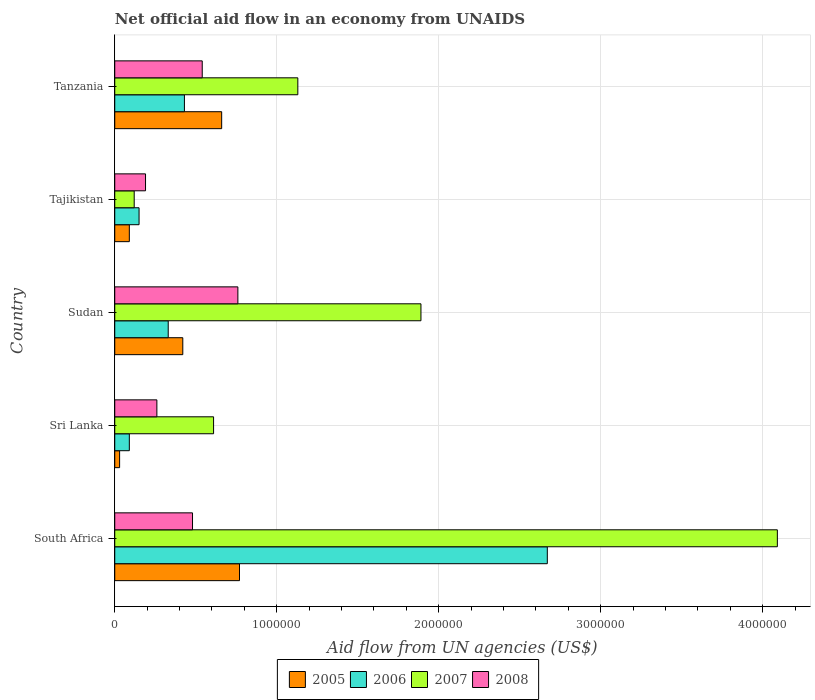Are the number of bars per tick equal to the number of legend labels?
Give a very brief answer. Yes. Are the number of bars on each tick of the Y-axis equal?
Ensure brevity in your answer.  Yes. How many bars are there on the 2nd tick from the top?
Give a very brief answer. 4. What is the label of the 5th group of bars from the top?
Ensure brevity in your answer.  South Africa. In how many cases, is the number of bars for a given country not equal to the number of legend labels?
Your response must be concise. 0. What is the net official aid flow in 2008 in Tajikistan?
Your response must be concise. 1.90e+05. Across all countries, what is the maximum net official aid flow in 2006?
Your response must be concise. 2.67e+06. In which country was the net official aid flow in 2007 maximum?
Your answer should be very brief. South Africa. In which country was the net official aid flow in 2007 minimum?
Ensure brevity in your answer.  Tajikistan. What is the total net official aid flow in 2007 in the graph?
Your response must be concise. 7.84e+06. What is the average net official aid flow in 2006 per country?
Provide a short and direct response. 7.34e+05. What is the difference between the net official aid flow in 2006 and net official aid flow in 2007 in Tanzania?
Give a very brief answer. -7.00e+05. In how many countries, is the net official aid flow in 2007 greater than 2000000 US$?
Give a very brief answer. 1. What is the ratio of the net official aid flow in 2005 in South Africa to that in Sri Lanka?
Provide a succinct answer. 25.67. What is the difference between the highest and the second highest net official aid flow in 2005?
Give a very brief answer. 1.10e+05. What is the difference between the highest and the lowest net official aid flow in 2007?
Your answer should be compact. 3.97e+06. Is it the case that in every country, the sum of the net official aid flow in 2008 and net official aid flow in 2007 is greater than the sum of net official aid flow in 2006 and net official aid flow in 2005?
Ensure brevity in your answer.  No. Is it the case that in every country, the sum of the net official aid flow in 2006 and net official aid flow in 2008 is greater than the net official aid flow in 2005?
Make the answer very short. Yes. What is the difference between two consecutive major ticks on the X-axis?
Offer a terse response. 1.00e+06. Does the graph contain grids?
Offer a very short reply. Yes. How are the legend labels stacked?
Give a very brief answer. Horizontal. What is the title of the graph?
Your answer should be compact. Net official aid flow in an economy from UNAIDS. What is the label or title of the X-axis?
Ensure brevity in your answer.  Aid flow from UN agencies (US$). What is the Aid flow from UN agencies (US$) in 2005 in South Africa?
Offer a very short reply. 7.70e+05. What is the Aid flow from UN agencies (US$) in 2006 in South Africa?
Give a very brief answer. 2.67e+06. What is the Aid flow from UN agencies (US$) in 2007 in South Africa?
Provide a short and direct response. 4.09e+06. What is the Aid flow from UN agencies (US$) in 2008 in South Africa?
Keep it short and to the point. 4.80e+05. What is the Aid flow from UN agencies (US$) in 2006 in Sri Lanka?
Make the answer very short. 9.00e+04. What is the Aid flow from UN agencies (US$) in 2005 in Sudan?
Provide a short and direct response. 4.20e+05. What is the Aid flow from UN agencies (US$) of 2006 in Sudan?
Offer a terse response. 3.30e+05. What is the Aid flow from UN agencies (US$) in 2007 in Sudan?
Give a very brief answer. 1.89e+06. What is the Aid flow from UN agencies (US$) in 2008 in Sudan?
Give a very brief answer. 7.60e+05. What is the Aid flow from UN agencies (US$) in 2005 in Tajikistan?
Ensure brevity in your answer.  9.00e+04. What is the Aid flow from UN agencies (US$) in 2007 in Tajikistan?
Keep it short and to the point. 1.20e+05. What is the Aid flow from UN agencies (US$) in 2008 in Tajikistan?
Ensure brevity in your answer.  1.90e+05. What is the Aid flow from UN agencies (US$) in 2005 in Tanzania?
Make the answer very short. 6.60e+05. What is the Aid flow from UN agencies (US$) of 2006 in Tanzania?
Your response must be concise. 4.30e+05. What is the Aid flow from UN agencies (US$) of 2007 in Tanzania?
Ensure brevity in your answer.  1.13e+06. What is the Aid flow from UN agencies (US$) of 2008 in Tanzania?
Keep it short and to the point. 5.40e+05. Across all countries, what is the maximum Aid flow from UN agencies (US$) of 2005?
Your answer should be compact. 7.70e+05. Across all countries, what is the maximum Aid flow from UN agencies (US$) of 2006?
Offer a very short reply. 2.67e+06. Across all countries, what is the maximum Aid flow from UN agencies (US$) of 2007?
Your response must be concise. 4.09e+06. Across all countries, what is the maximum Aid flow from UN agencies (US$) of 2008?
Offer a very short reply. 7.60e+05. Across all countries, what is the minimum Aid flow from UN agencies (US$) in 2005?
Offer a very short reply. 3.00e+04. Across all countries, what is the minimum Aid flow from UN agencies (US$) of 2008?
Make the answer very short. 1.90e+05. What is the total Aid flow from UN agencies (US$) of 2005 in the graph?
Provide a succinct answer. 1.97e+06. What is the total Aid flow from UN agencies (US$) of 2006 in the graph?
Your response must be concise. 3.67e+06. What is the total Aid flow from UN agencies (US$) in 2007 in the graph?
Provide a succinct answer. 7.84e+06. What is the total Aid flow from UN agencies (US$) of 2008 in the graph?
Offer a terse response. 2.23e+06. What is the difference between the Aid flow from UN agencies (US$) in 2005 in South Africa and that in Sri Lanka?
Provide a succinct answer. 7.40e+05. What is the difference between the Aid flow from UN agencies (US$) in 2006 in South Africa and that in Sri Lanka?
Make the answer very short. 2.58e+06. What is the difference between the Aid flow from UN agencies (US$) in 2007 in South Africa and that in Sri Lanka?
Ensure brevity in your answer.  3.48e+06. What is the difference between the Aid flow from UN agencies (US$) in 2008 in South Africa and that in Sri Lanka?
Provide a succinct answer. 2.20e+05. What is the difference between the Aid flow from UN agencies (US$) of 2006 in South Africa and that in Sudan?
Make the answer very short. 2.34e+06. What is the difference between the Aid flow from UN agencies (US$) in 2007 in South Africa and that in Sudan?
Give a very brief answer. 2.20e+06. What is the difference between the Aid flow from UN agencies (US$) of 2008 in South Africa and that in Sudan?
Offer a very short reply. -2.80e+05. What is the difference between the Aid flow from UN agencies (US$) of 2005 in South Africa and that in Tajikistan?
Your answer should be compact. 6.80e+05. What is the difference between the Aid flow from UN agencies (US$) in 2006 in South Africa and that in Tajikistan?
Your answer should be very brief. 2.52e+06. What is the difference between the Aid flow from UN agencies (US$) in 2007 in South Africa and that in Tajikistan?
Your answer should be very brief. 3.97e+06. What is the difference between the Aid flow from UN agencies (US$) of 2008 in South Africa and that in Tajikistan?
Ensure brevity in your answer.  2.90e+05. What is the difference between the Aid flow from UN agencies (US$) in 2006 in South Africa and that in Tanzania?
Provide a succinct answer. 2.24e+06. What is the difference between the Aid flow from UN agencies (US$) of 2007 in South Africa and that in Tanzania?
Your answer should be very brief. 2.96e+06. What is the difference between the Aid flow from UN agencies (US$) in 2005 in Sri Lanka and that in Sudan?
Your answer should be very brief. -3.90e+05. What is the difference between the Aid flow from UN agencies (US$) of 2006 in Sri Lanka and that in Sudan?
Give a very brief answer. -2.40e+05. What is the difference between the Aid flow from UN agencies (US$) in 2007 in Sri Lanka and that in Sudan?
Your answer should be very brief. -1.28e+06. What is the difference between the Aid flow from UN agencies (US$) in 2008 in Sri Lanka and that in Sudan?
Your answer should be compact. -5.00e+05. What is the difference between the Aid flow from UN agencies (US$) of 2005 in Sri Lanka and that in Tanzania?
Your answer should be compact. -6.30e+05. What is the difference between the Aid flow from UN agencies (US$) of 2007 in Sri Lanka and that in Tanzania?
Provide a succinct answer. -5.20e+05. What is the difference between the Aid flow from UN agencies (US$) of 2008 in Sri Lanka and that in Tanzania?
Keep it short and to the point. -2.80e+05. What is the difference between the Aid flow from UN agencies (US$) in 2005 in Sudan and that in Tajikistan?
Give a very brief answer. 3.30e+05. What is the difference between the Aid flow from UN agencies (US$) of 2007 in Sudan and that in Tajikistan?
Your response must be concise. 1.77e+06. What is the difference between the Aid flow from UN agencies (US$) of 2008 in Sudan and that in Tajikistan?
Your answer should be very brief. 5.70e+05. What is the difference between the Aid flow from UN agencies (US$) in 2005 in Sudan and that in Tanzania?
Your answer should be very brief. -2.40e+05. What is the difference between the Aid flow from UN agencies (US$) of 2006 in Sudan and that in Tanzania?
Your answer should be very brief. -1.00e+05. What is the difference between the Aid flow from UN agencies (US$) in 2007 in Sudan and that in Tanzania?
Your answer should be very brief. 7.60e+05. What is the difference between the Aid flow from UN agencies (US$) in 2005 in Tajikistan and that in Tanzania?
Provide a short and direct response. -5.70e+05. What is the difference between the Aid flow from UN agencies (US$) in 2006 in Tajikistan and that in Tanzania?
Your answer should be very brief. -2.80e+05. What is the difference between the Aid flow from UN agencies (US$) in 2007 in Tajikistan and that in Tanzania?
Give a very brief answer. -1.01e+06. What is the difference between the Aid flow from UN agencies (US$) of 2008 in Tajikistan and that in Tanzania?
Provide a succinct answer. -3.50e+05. What is the difference between the Aid flow from UN agencies (US$) in 2005 in South Africa and the Aid flow from UN agencies (US$) in 2006 in Sri Lanka?
Your answer should be very brief. 6.80e+05. What is the difference between the Aid flow from UN agencies (US$) in 2005 in South Africa and the Aid flow from UN agencies (US$) in 2007 in Sri Lanka?
Offer a terse response. 1.60e+05. What is the difference between the Aid flow from UN agencies (US$) of 2005 in South Africa and the Aid flow from UN agencies (US$) of 2008 in Sri Lanka?
Offer a very short reply. 5.10e+05. What is the difference between the Aid flow from UN agencies (US$) in 2006 in South Africa and the Aid flow from UN agencies (US$) in 2007 in Sri Lanka?
Your response must be concise. 2.06e+06. What is the difference between the Aid flow from UN agencies (US$) in 2006 in South Africa and the Aid flow from UN agencies (US$) in 2008 in Sri Lanka?
Your response must be concise. 2.41e+06. What is the difference between the Aid flow from UN agencies (US$) of 2007 in South Africa and the Aid flow from UN agencies (US$) of 2008 in Sri Lanka?
Your answer should be very brief. 3.83e+06. What is the difference between the Aid flow from UN agencies (US$) in 2005 in South Africa and the Aid flow from UN agencies (US$) in 2006 in Sudan?
Offer a very short reply. 4.40e+05. What is the difference between the Aid flow from UN agencies (US$) of 2005 in South Africa and the Aid flow from UN agencies (US$) of 2007 in Sudan?
Provide a succinct answer. -1.12e+06. What is the difference between the Aid flow from UN agencies (US$) in 2006 in South Africa and the Aid flow from UN agencies (US$) in 2007 in Sudan?
Your answer should be compact. 7.80e+05. What is the difference between the Aid flow from UN agencies (US$) of 2006 in South Africa and the Aid flow from UN agencies (US$) of 2008 in Sudan?
Provide a short and direct response. 1.91e+06. What is the difference between the Aid flow from UN agencies (US$) in 2007 in South Africa and the Aid flow from UN agencies (US$) in 2008 in Sudan?
Provide a short and direct response. 3.33e+06. What is the difference between the Aid flow from UN agencies (US$) in 2005 in South Africa and the Aid flow from UN agencies (US$) in 2006 in Tajikistan?
Keep it short and to the point. 6.20e+05. What is the difference between the Aid flow from UN agencies (US$) of 2005 in South Africa and the Aid flow from UN agencies (US$) of 2007 in Tajikistan?
Your response must be concise. 6.50e+05. What is the difference between the Aid flow from UN agencies (US$) in 2005 in South Africa and the Aid flow from UN agencies (US$) in 2008 in Tajikistan?
Offer a terse response. 5.80e+05. What is the difference between the Aid flow from UN agencies (US$) in 2006 in South Africa and the Aid flow from UN agencies (US$) in 2007 in Tajikistan?
Provide a short and direct response. 2.55e+06. What is the difference between the Aid flow from UN agencies (US$) of 2006 in South Africa and the Aid flow from UN agencies (US$) of 2008 in Tajikistan?
Offer a very short reply. 2.48e+06. What is the difference between the Aid flow from UN agencies (US$) of 2007 in South Africa and the Aid flow from UN agencies (US$) of 2008 in Tajikistan?
Your answer should be very brief. 3.90e+06. What is the difference between the Aid flow from UN agencies (US$) of 2005 in South Africa and the Aid flow from UN agencies (US$) of 2006 in Tanzania?
Ensure brevity in your answer.  3.40e+05. What is the difference between the Aid flow from UN agencies (US$) in 2005 in South Africa and the Aid flow from UN agencies (US$) in 2007 in Tanzania?
Offer a terse response. -3.60e+05. What is the difference between the Aid flow from UN agencies (US$) of 2006 in South Africa and the Aid flow from UN agencies (US$) of 2007 in Tanzania?
Offer a terse response. 1.54e+06. What is the difference between the Aid flow from UN agencies (US$) of 2006 in South Africa and the Aid flow from UN agencies (US$) of 2008 in Tanzania?
Give a very brief answer. 2.13e+06. What is the difference between the Aid flow from UN agencies (US$) in 2007 in South Africa and the Aid flow from UN agencies (US$) in 2008 in Tanzania?
Your answer should be compact. 3.55e+06. What is the difference between the Aid flow from UN agencies (US$) in 2005 in Sri Lanka and the Aid flow from UN agencies (US$) in 2007 in Sudan?
Provide a succinct answer. -1.86e+06. What is the difference between the Aid flow from UN agencies (US$) in 2005 in Sri Lanka and the Aid flow from UN agencies (US$) in 2008 in Sudan?
Your answer should be compact. -7.30e+05. What is the difference between the Aid flow from UN agencies (US$) in 2006 in Sri Lanka and the Aid flow from UN agencies (US$) in 2007 in Sudan?
Ensure brevity in your answer.  -1.80e+06. What is the difference between the Aid flow from UN agencies (US$) in 2006 in Sri Lanka and the Aid flow from UN agencies (US$) in 2008 in Sudan?
Give a very brief answer. -6.70e+05. What is the difference between the Aid flow from UN agencies (US$) of 2005 in Sri Lanka and the Aid flow from UN agencies (US$) of 2007 in Tajikistan?
Keep it short and to the point. -9.00e+04. What is the difference between the Aid flow from UN agencies (US$) in 2006 in Sri Lanka and the Aid flow from UN agencies (US$) in 2008 in Tajikistan?
Offer a very short reply. -1.00e+05. What is the difference between the Aid flow from UN agencies (US$) in 2007 in Sri Lanka and the Aid flow from UN agencies (US$) in 2008 in Tajikistan?
Ensure brevity in your answer.  4.20e+05. What is the difference between the Aid flow from UN agencies (US$) of 2005 in Sri Lanka and the Aid flow from UN agencies (US$) of 2006 in Tanzania?
Offer a very short reply. -4.00e+05. What is the difference between the Aid flow from UN agencies (US$) in 2005 in Sri Lanka and the Aid flow from UN agencies (US$) in 2007 in Tanzania?
Your answer should be very brief. -1.10e+06. What is the difference between the Aid flow from UN agencies (US$) of 2005 in Sri Lanka and the Aid flow from UN agencies (US$) of 2008 in Tanzania?
Ensure brevity in your answer.  -5.10e+05. What is the difference between the Aid flow from UN agencies (US$) of 2006 in Sri Lanka and the Aid flow from UN agencies (US$) of 2007 in Tanzania?
Keep it short and to the point. -1.04e+06. What is the difference between the Aid flow from UN agencies (US$) in 2006 in Sri Lanka and the Aid flow from UN agencies (US$) in 2008 in Tanzania?
Keep it short and to the point. -4.50e+05. What is the difference between the Aid flow from UN agencies (US$) of 2007 in Sri Lanka and the Aid flow from UN agencies (US$) of 2008 in Tanzania?
Keep it short and to the point. 7.00e+04. What is the difference between the Aid flow from UN agencies (US$) in 2006 in Sudan and the Aid flow from UN agencies (US$) in 2007 in Tajikistan?
Offer a very short reply. 2.10e+05. What is the difference between the Aid flow from UN agencies (US$) in 2007 in Sudan and the Aid flow from UN agencies (US$) in 2008 in Tajikistan?
Ensure brevity in your answer.  1.70e+06. What is the difference between the Aid flow from UN agencies (US$) of 2005 in Sudan and the Aid flow from UN agencies (US$) of 2007 in Tanzania?
Your response must be concise. -7.10e+05. What is the difference between the Aid flow from UN agencies (US$) of 2006 in Sudan and the Aid flow from UN agencies (US$) of 2007 in Tanzania?
Offer a terse response. -8.00e+05. What is the difference between the Aid flow from UN agencies (US$) of 2007 in Sudan and the Aid flow from UN agencies (US$) of 2008 in Tanzania?
Offer a terse response. 1.35e+06. What is the difference between the Aid flow from UN agencies (US$) in 2005 in Tajikistan and the Aid flow from UN agencies (US$) in 2007 in Tanzania?
Offer a terse response. -1.04e+06. What is the difference between the Aid flow from UN agencies (US$) of 2005 in Tajikistan and the Aid flow from UN agencies (US$) of 2008 in Tanzania?
Offer a very short reply. -4.50e+05. What is the difference between the Aid flow from UN agencies (US$) in 2006 in Tajikistan and the Aid flow from UN agencies (US$) in 2007 in Tanzania?
Offer a very short reply. -9.80e+05. What is the difference between the Aid flow from UN agencies (US$) of 2006 in Tajikistan and the Aid flow from UN agencies (US$) of 2008 in Tanzania?
Keep it short and to the point. -3.90e+05. What is the difference between the Aid flow from UN agencies (US$) in 2007 in Tajikistan and the Aid flow from UN agencies (US$) in 2008 in Tanzania?
Make the answer very short. -4.20e+05. What is the average Aid flow from UN agencies (US$) in 2005 per country?
Ensure brevity in your answer.  3.94e+05. What is the average Aid flow from UN agencies (US$) in 2006 per country?
Offer a very short reply. 7.34e+05. What is the average Aid flow from UN agencies (US$) in 2007 per country?
Provide a short and direct response. 1.57e+06. What is the average Aid flow from UN agencies (US$) in 2008 per country?
Your response must be concise. 4.46e+05. What is the difference between the Aid flow from UN agencies (US$) in 2005 and Aid flow from UN agencies (US$) in 2006 in South Africa?
Offer a very short reply. -1.90e+06. What is the difference between the Aid flow from UN agencies (US$) of 2005 and Aid flow from UN agencies (US$) of 2007 in South Africa?
Offer a very short reply. -3.32e+06. What is the difference between the Aid flow from UN agencies (US$) in 2005 and Aid flow from UN agencies (US$) in 2008 in South Africa?
Make the answer very short. 2.90e+05. What is the difference between the Aid flow from UN agencies (US$) of 2006 and Aid flow from UN agencies (US$) of 2007 in South Africa?
Give a very brief answer. -1.42e+06. What is the difference between the Aid flow from UN agencies (US$) of 2006 and Aid flow from UN agencies (US$) of 2008 in South Africa?
Make the answer very short. 2.19e+06. What is the difference between the Aid flow from UN agencies (US$) in 2007 and Aid flow from UN agencies (US$) in 2008 in South Africa?
Give a very brief answer. 3.61e+06. What is the difference between the Aid flow from UN agencies (US$) in 2005 and Aid flow from UN agencies (US$) in 2006 in Sri Lanka?
Offer a very short reply. -6.00e+04. What is the difference between the Aid flow from UN agencies (US$) in 2005 and Aid flow from UN agencies (US$) in 2007 in Sri Lanka?
Your answer should be compact. -5.80e+05. What is the difference between the Aid flow from UN agencies (US$) of 2006 and Aid flow from UN agencies (US$) of 2007 in Sri Lanka?
Provide a short and direct response. -5.20e+05. What is the difference between the Aid flow from UN agencies (US$) of 2007 and Aid flow from UN agencies (US$) of 2008 in Sri Lanka?
Provide a succinct answer. 3.50e+05. What is the difference between the Aid flow from UN agencies (US$) of 2005 and Aid flow from UN agencies (US$) of 2006 in Sudan?
Keep it short and to the point. 9.00e+04. What is the difference between the Aid flow from UN agencies (US$) in 2005 and Aid flow from UN agencies (US$) in 2007 in Sudan?
Your answer should be compact. -1.47e+06. What is the difference between the Aid flow from UN agencies (US$) of 2006 and Aid flow from UN agencies (US$) of 2007 in Sudan?
Provide a succinct answer. -1.56e+06. What is the difference between the Aid flow from UN agencies (US$) in 2006 and Aid flow from UN agencies (US$) in 2008 in Sudan?
Your answer should be very brief. -4.30e+05. What is the difference between the Aid flow from UN agencies (US$) in 2007 and Aid flow from UN agencies (US$) in 2008 in Sudan?
Provide a short and direct response. 1.13e+06. What is the difference between the Aid flow from UN agencies (US$) in 2005 and Aid flow from UN agencies (US$) in 2006 in Tajikistan?
Ensure brevity in your answer.  -6.00e+04. What is the difference between the Aid flow from UN agencies (US$) of 2005 and Aid flow from UN agencies (US$) of 2007 in Tanzania?
Provide a short and direct response. -4.70e+05. What is the difference between the Aid flow from UN agencies (US$) of 2005 and Aid flow from UN agencies (US$) of 2008 in Tanzania?
Keep it short and to the point. 1.20e+05. What is the difference between the Aid flow from UN agencies (US$) in 2006 and Aid flow from UN agencies (US$) in 2007 in Tanzania?
Offer a very short reply. -7.00e+05. What is the difference between the Aid flow from UN agencies (US$) of 2007 and Aid flow from UN agencies (US$) of 2008 in Tanzania?
Keep it short and to the point. 5.90e+05. What is the ratio of the Aid flow from UN agencies (US$) in 2005 in South Africa to that in Sri Lanka?
Give a very brief answer. 25.67. What is the ratio of the Aid flow from UN agencies (US$) of 2006 in South Africa to that in Sri Lanka?
Ensure brevity in your answer.  29.67. What is the ratio of the Aid flow from UN agencies (US$) in 2007 in South Africa to that in Sri Lanka?
Offer a terse response. 6.7. What is the ratio of the Aid flow from UN agencies (US$) in 2008 in South Africa to that in Sri Lanka?
Your response must be concise. 1.85. What is the ratio of the Aid flow from UN agencies (US$) of 2005 in South Africa to that in Sudan?
Provide a short and direct response. 1.83. What is the ratio of the Aid flow from UN agencies (US$) in 2006 in South Africa to that in Sudan?
Offer a terse response. 8.09. What is the ratio of the Aid flow from UN agencies (US$) of 2007 in South Africa to that in Sudan?
Your response must be concise. 2.16. What is the ratio of the Aid flow from UN agencies (US$) in 2008 in South Africa to that in Sudan?
Keep it short and to the point. 0.63. What is the ratio of the Aid flow from UN agencies (US$) of 2005 in South Africa to that in Tajikistan?
Ensure brevity in your answer.  8.56. What is the ratio of the Aid flow from UN agencies (US$) in 2007 in South Africa to that in Tajikistan?
Your answer should be compact. 34.08. What is the ratio of the Aid flow from UN agencies (US$) in 2008 in South Africa to that in Tajikistan?
Offer a very short reply. 2.53. What is the ratio of the Aid flow from UN agencies (US$) in 2006 in South Africa to that in Tanzania?
Ensure brevity in your answer.  6.21. What is the ratio of the Aid flow from UN agencies (US$) of 2007 in South Africa to that in Tanzania?
Your answer should be compact. 3.62. What is the ratio of the Aid flow from UN agencies (US$) of 2005 in Sri Lanka to that in Sudan?
Ensure brevity in your answer.  0.07. What is the ratio of the Aid flow from UN agencies (US$) of 2006 in Sri Lanka to that in Sudan?
Your answer should be very brief. 0.27. What is the ratio of the Aid flow from UN agencies (US$) in 2007 in Sri Lanka to that in Sudan?
Provide a short and direct response. 0.32. What is the ratio of the Aid flow from UN agencies (US$) in 2008 in Sri Lanka to that in Sudan?
Provide a short and direct response. 0.34. What is the ratio of the Aid flow from UN agencies (US$) in 2007 in Sri Lanka to that in Tajikistan?
Keep it short and to the point. 5.08. What is the ratio of the Aid flow from UN agencies (US$) of 2008 in Sri Lanka to that in Tajikistan?
Give a very brief answer. 1.37. What is the ratio of the Aid flow from UN agencies (US$) of 2005 in Sri Lanka to that in Tanzania?
Offer a terse response. 0.05. What is the ratio of the Aid flow from UN agencies (US$) of 2006 in Sri Lanka to that in Tanzania?
Keep it short and to the point. 0.21. What is the ratio of the Aid flow from UN agencies (US$) of 2007 in Sri Lanka to that in Tanzania?
Your answer should be compact. 0.54. What is the ratio of the Aid flow from UN agencies (US$) in 2008 in Sri Lanka to that in Tanzania?
Offer a very short reply. 0.48. What is the ratio of the Aid flow from UN agencies (US$) of 2005 in Sudan to that in Tajikistan?
Keep it short and to the point. 4.67. What is the ratio of the Aid flow from UN agencies (US$) of 2007 in Sudan to that in Tajikistan?
Your answer should be very brief. 15.75. What is the ratio of the Aid flow from UN agencies (US$) of 2008 in Sudan to that in Tajikistan?
Provide a succinct answer. 4. What is the ratio of the Aid flow from UN agencies (US$) of 2005 in Sudan to that in Tanzania?
Provide a short and direct response. 0.64. What is the ratio of the Aid flow from UN agencies (US$) of 2006 in Sudan to that in Tanzania?
Offer a very short reply. 0.77. What is the ratio of the Aid flow from UN agencies (US$) in 2007 in Sudan to that in Tanzania?
Your answer should be very brief. 1.67. What is the ratio of the Aid flow from UN agencies (US$) of 2008 in Sudan to that in Tanzania?
Provide a short and direct response. 1.41. What is the ratio of the Aid flow from UN agencies (US$) of 2005 in Tajikistan to that in Tanzania?
Keep it short and to the point. 0.14. What is the ratio of the Aid flow from UN agencies (US$) of 2006 in Tajikistan to that in Tanzania?
Your answer should be very brief. 0.35. What is the ratio of the Aid flow from UN agencies (US$) of 2007 in Tajikistan to that in Tanzania?
Offer a very short reply. 0.11. What is the ratio of the Aid flow from UN agencies (US$) in 2008 in Tajikistan to that in Tanzania?
Your response must be concise. 0.35. What is the difference between the highest and the second highest Aid flow from UN agencies (US$) in 2005?
Provide a short and direct response. 1.10e+05. What is the difference between the highest and the second highest Aid flow from UN agencies (US$) in 2006?
Your answer should be very brief. 2.24e+06. What is the difference between the highest and the second highest Aid flow from UN agencies (US$) of 2007?
Keep it short and to the point. 2.20e+06. What is the difference between the highest and the second highest Aid flow from UN agencies (US$) of 2008?
Provide a succinct answer. 2.20e+05. What is the difference between the highest and the lowest Aid flow from UN agencies (US$) in 2005?
Offer a very short reply. 7.40e+05. What is the difference between the highest and the lowest Aid flow from UN agencies (US$) in 2006?
Your answer should be compact. 2.58e+06. What is the difference between the highest and the lowest Aid flow from UN agencies (US$) in 2007?
Your response must be concise. 3.97e+06. What is the difference between the highest and the lowest Aid flow from UN agencies (US$) in 2008?
Provide a short and direct response. 5.70e+05. 